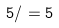Convert formula to latex. <formula><loc_0><loc_0><loc_500><loc_500>5 / = 5</formula> 